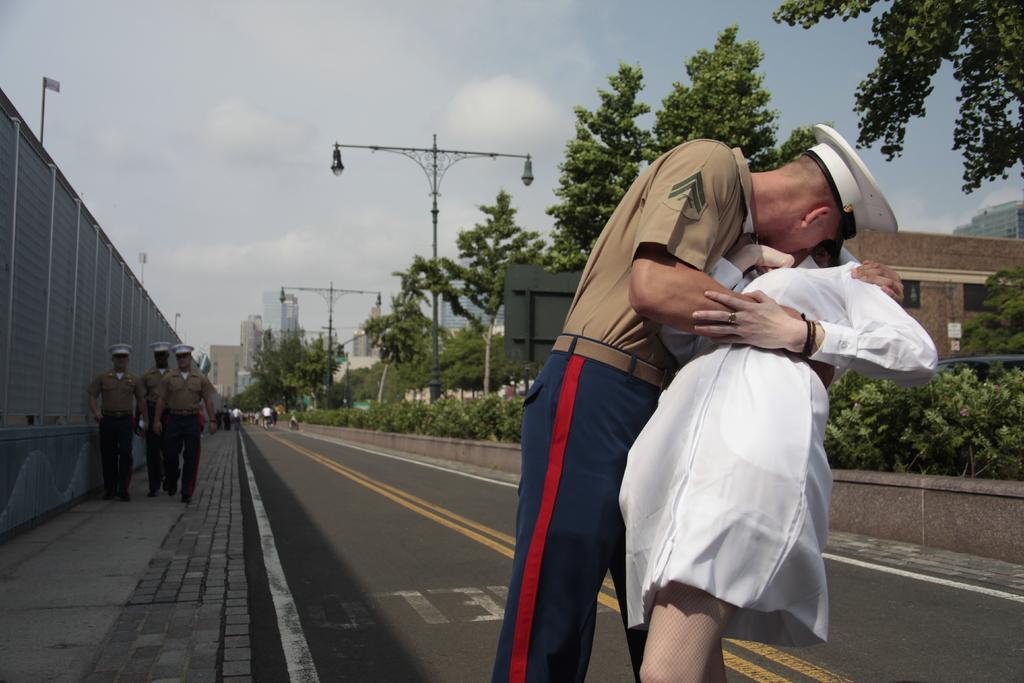Can you describe this image briefly? In this picture there is a man who is wearing cap, shirt and trouser. he is kissing to women who is wearing white dress. On the left there are three persons who are walking on the street. Here we can see many persons on the road. On the right background there is a building. On the divider we can see street lights and plants. On the top we can see sky and clouds. In the background we can see buildings, trees and crane. 